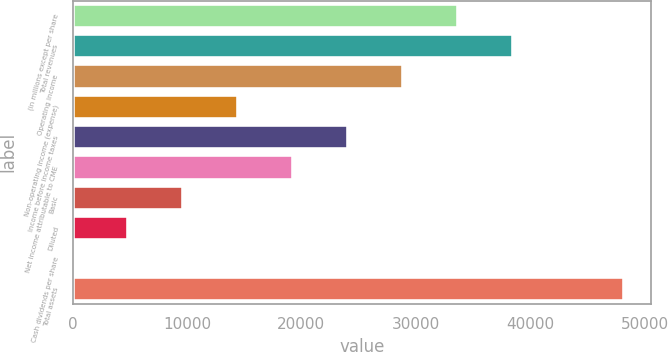<chart> <loc_0><loc_0><loc_500><loc_500><bar_chart><fcel>(in millions except per share<fcel>Total revenues<fcel>Operating income<fcel>Non-operating income (expense)<fcel>Income before income taxes<fcel>Net income attributable to CME<fcel>Basic<fcel>Diluted<fcel>Cash dividends per share<fcel>Total assets<nl><fcel>33714<fcel>38528.9<fcel>28899.1<fcel>14454.3<fcel>24084.2<fcel>19269.2<fcel>9639.42<fcel>4824.51<fcel>9.6<fcel>48158.7<nl></chart> 